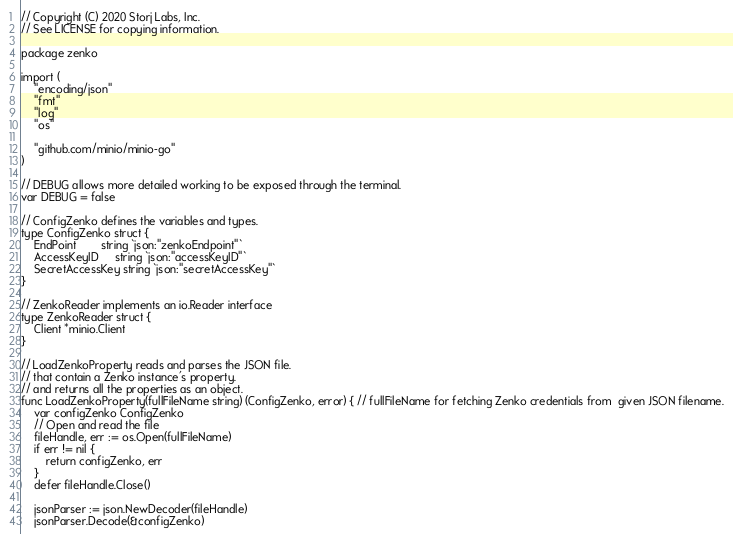<code> <loc_0><loc_0><loc_500><loc_500><_Go_>// Copyright (C) 2020 Storj Labs, Inc.
// See LICENSE for copying information.

package zenko

import (
	"encoding/json"
	"fmt"
	"log"
	"os"

	"github.com/minio/minio-go"
)

// DEBUG allows more detailed working to be exposed through the terminal.
var DEBUG = false

// ConfigZenko defines the variables and types.
type ConfigZenko struct {
	EndPoint        string `json:"zenkoEndpoint"`
	AccessKeyID     string `json:"accessKeyID"`
	SecretAccessKey string `json:"secretAccessKey"`
}

// ZenkoReader implements an io.Reader interface
type ZenkoReader struct {
	Client *minio.Client
}

// LoadZenkoProperty reads and parses the JSON file.
// that contain a Zenko instance's property.
// and returns all the properties as an object.
func LoadZenkoProperty(fullFileName string) (ConfigZenko, error) { // fullFileName for fetching Zenko credentials from  given JSON filename.
	var configZenko ConfigZenko
	// Open and read the file
	fileHandle, err := os.Open(fullFileName)
	if err != nil {
		return configZenko, err
	}
	defer fileHandle.Close()

	jsonParser := json.NewDecoder(fileHandle)
	jsonParser.Decode(&configZenko)
</code> 